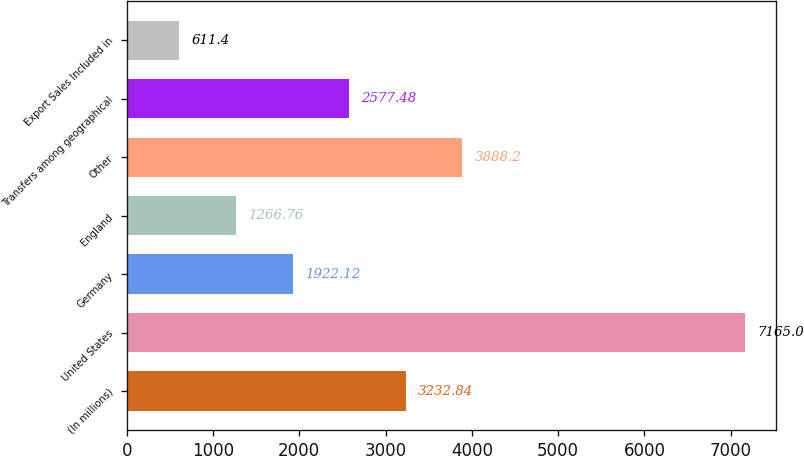Convert chart. <chart><loc_0><loc_0><loc_500><loc_500><bar_chart><fcel>(In millions)<fcel>United States<fcel>Germany<fcel>England<fcel>Other<fcel>Transfers among geographical<fcel>Export Sales Included in<nl><fcel>3232.84<fcel>7165<fcel>1922.12<fcel>1266.76<fcel>3888.2<fcel>2577.48<fcel>611.4<nl></chart> 